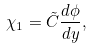Convert formula to latex. <formula><loc_0><loc_0><loc_500><loc_500>\chi _ { 1 } = \tilde { C } \frac { d \phi } { d y } ,</formula> 